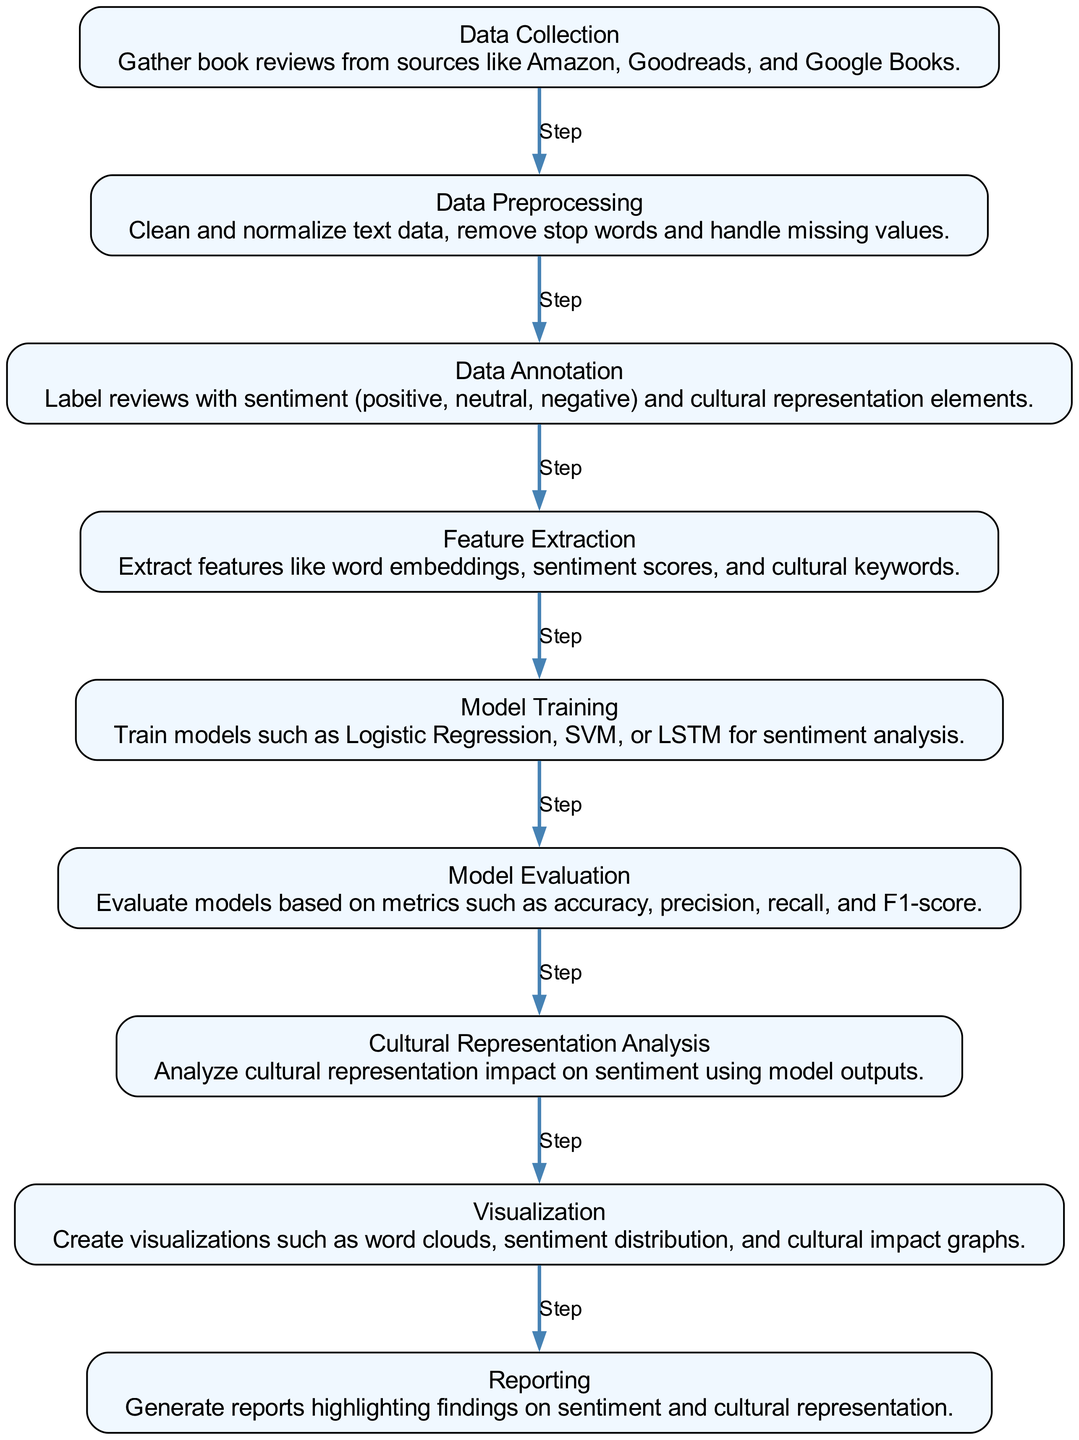What is the first step in the diagram? The first step is "Data Collection", which is indicated as the starting node in the diagram. It collects book reviews from various sources.
Answer: Data Collection How many nodes are there in the diagram? By counting the nodes listed, there are a total of 9 nodes that represent different steps in the machine learning process for sentiment analysis.
Answer: 9 What step comes after Data Preprocessing? The step that comes after "Data Preprocessing" is "Data Annotation", as indicated by the directed edge leading from the second node to the third node in the diagram.
Answer: Data Annotation What is the focus of the analysis in the last step? The last step focuses on "Reporting", which highlights the findings regarding sentiment and cultural representation based on the analysis performed in earlier steps.
Answer: Reporting Which model types are used in the Model Training step? The "Model Training" step mentions using Logistic Regression, SVM, or LSTM for sentiment analysis. This can be inferred as listed in the description for that node.
Answer: Logistic Regression, SVM, LSTM How is cultural representation analyzed in the process? Cultural representation is analyzed as part of the "Cultural Representation Analysis" step that follows "Model Evaluation", where outputs are examined to understand cultural representation's impact on sentiment.
Answer: Cultural Representation Analysis Which node comes before Visualization? The node that comes before "Visualization" is "Cultural Representation Analysis," shown as the step immediately preceding visualization in the flow of the diagram.
Answer: Cultural Representation Analysis What process is indicated by edges connecting multiple nodes? The edges indicate the sequential flow of the machine learning process, showing that each step follows logically from the previous one, forming a workflow for the analysis.
Answer: Workflow What key metrics are used to evaluate the models? The model evaluation uses metrics such as accuracy, precision, recall, and F1-score as commonly listed in the description of the "Model Evaluation" node.
Answer: Accuracy, precision, recall, F1-score 